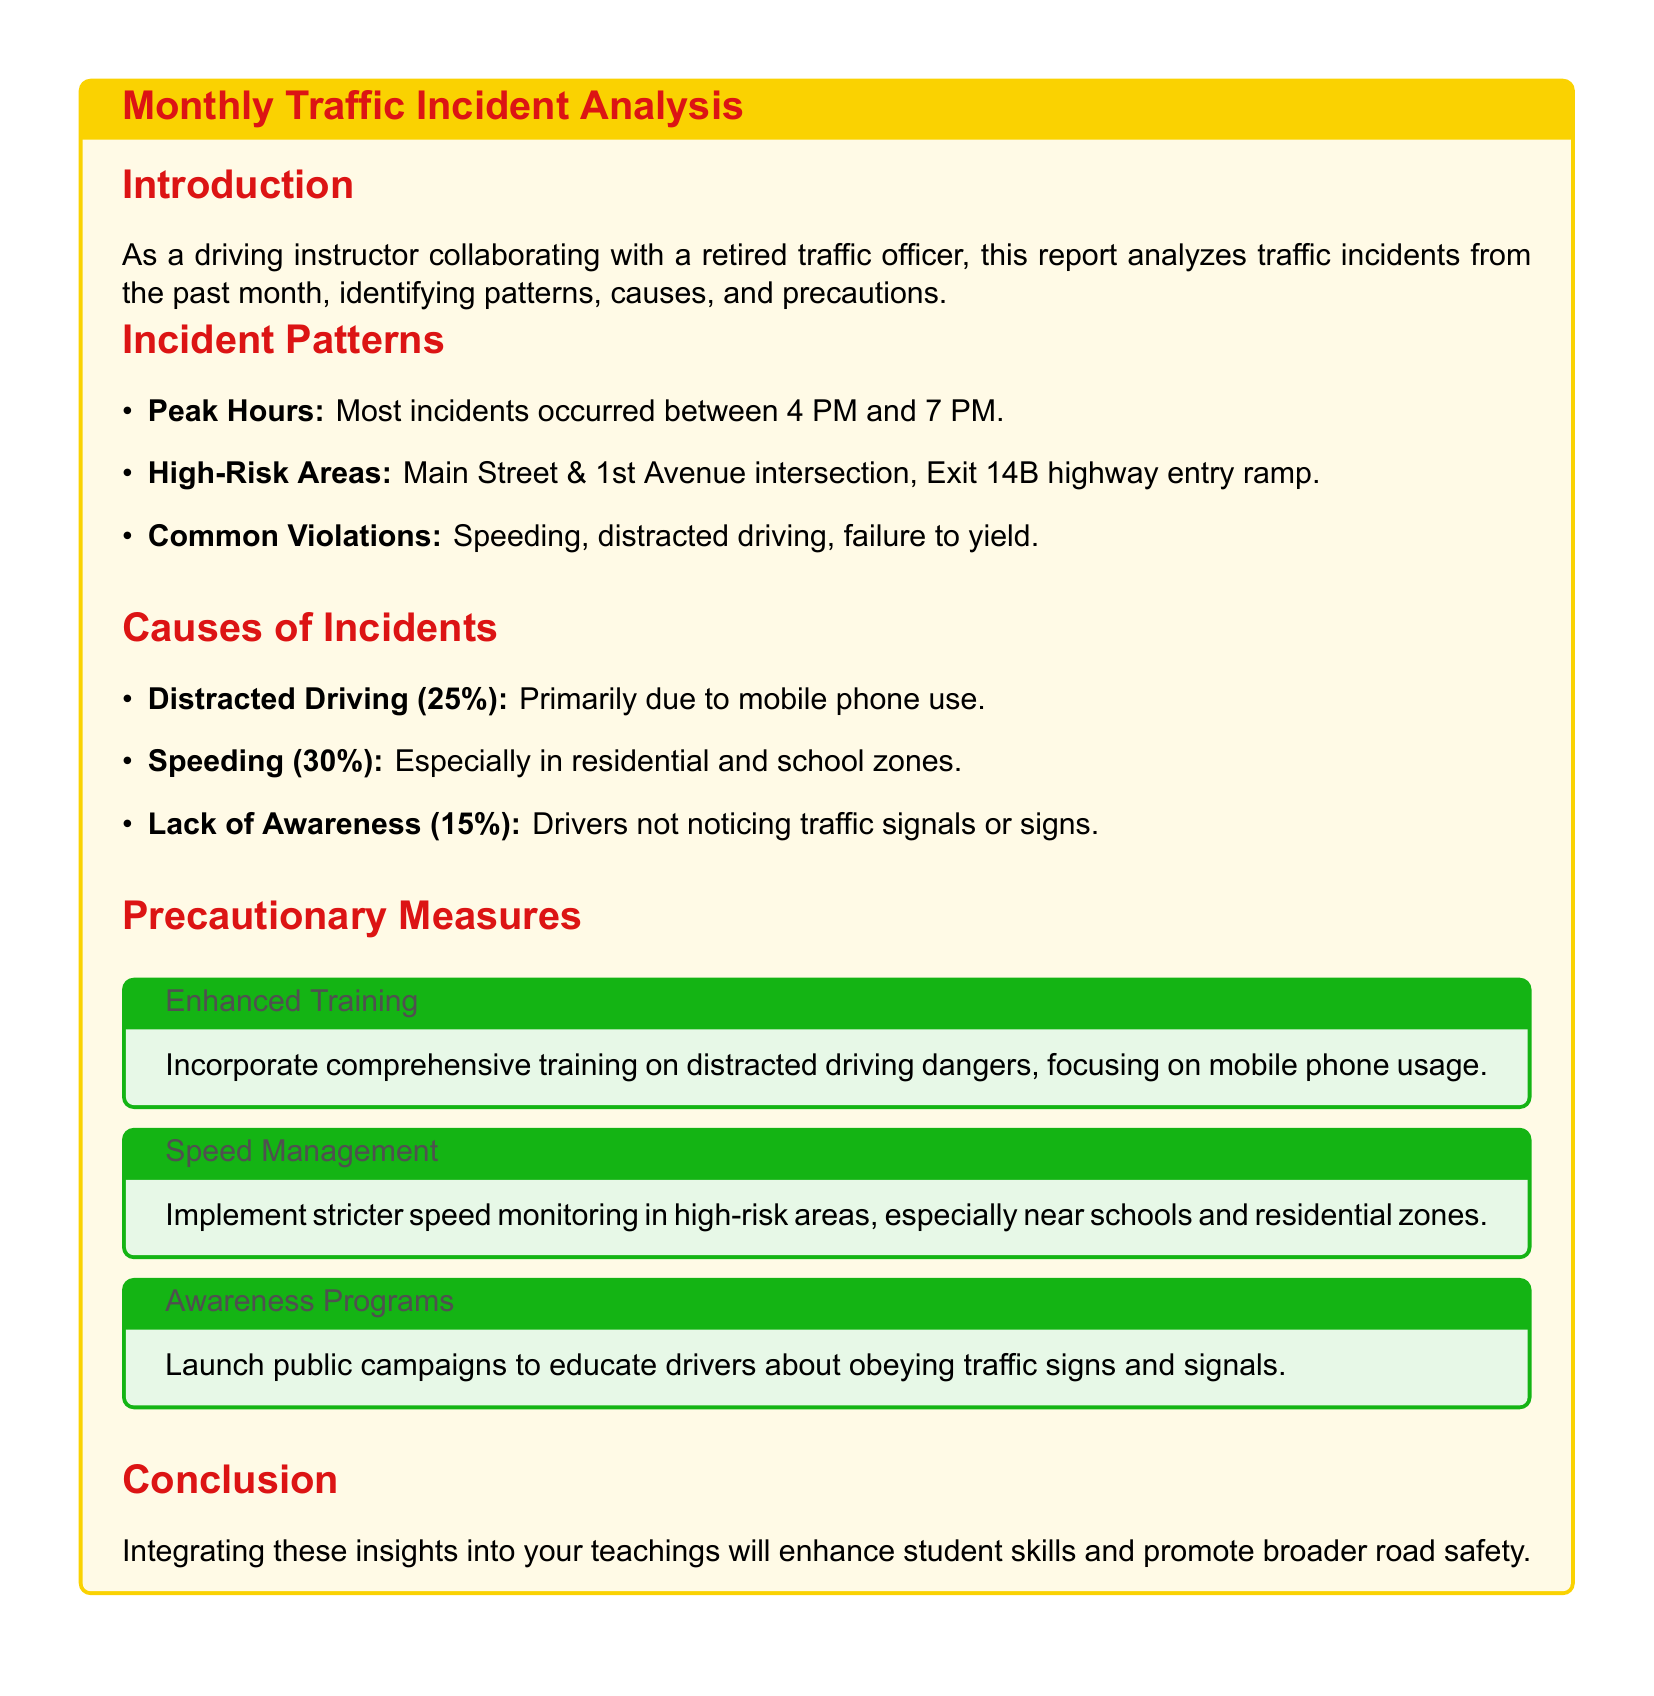What time do most incidents occur? Most incidents occurred between 4 PM and 7 PM, as mentioned in the document.
Answer: 4 PM to 7 PM What is the most common violation contributing to incidents? Speeding is noted as the most common violation contributing to incidents in the report.
Answer: Speeding What percentage of incidents are due to distracted driving? The document states that 25% of incidents are attributed to distracted driving.
Answer: 25% Which area is identified as a high-risk location for accidents? The Main Street & 1st Avenue intersection is specifically identified as a high-risk area.
Answer: Main Street & 1st Avenue intersection What precautionary measure is suggested for distracted driving? The report recommends incorporating comprehensive training on distracted driving dangers.
Answer: Comprehensive training How many percent of incidents are caused by speeding? According to the analysis, 30% of incidents are caused by speeding.
Answer: 30% What is recommended for speed management in high-risk areas? The report suggests implementing stricter speed monitoring in high-risk areas.
Answer: Stricter speed monitoring What type of campaigns are suggested to enhance driver awareness? The document advises launching public campaigns to educate drivers about obeying traffic signs and signals.
Answer: Public campaigns 